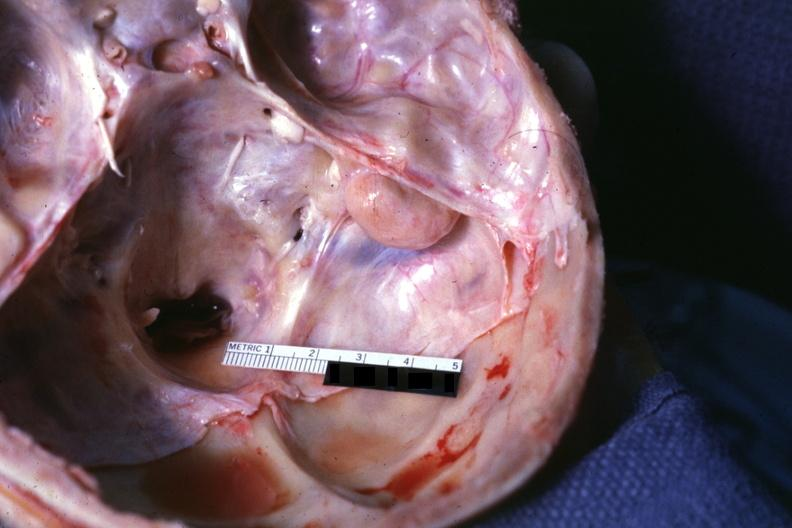s interesting case seen on surface right petrous bone?
Answer the question using a single word or phrase. No 